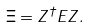<formula> <loc_0><loc_0><loc_500><loc_500>\Xi = Z ^ { \dagger } E Z .</formula> 